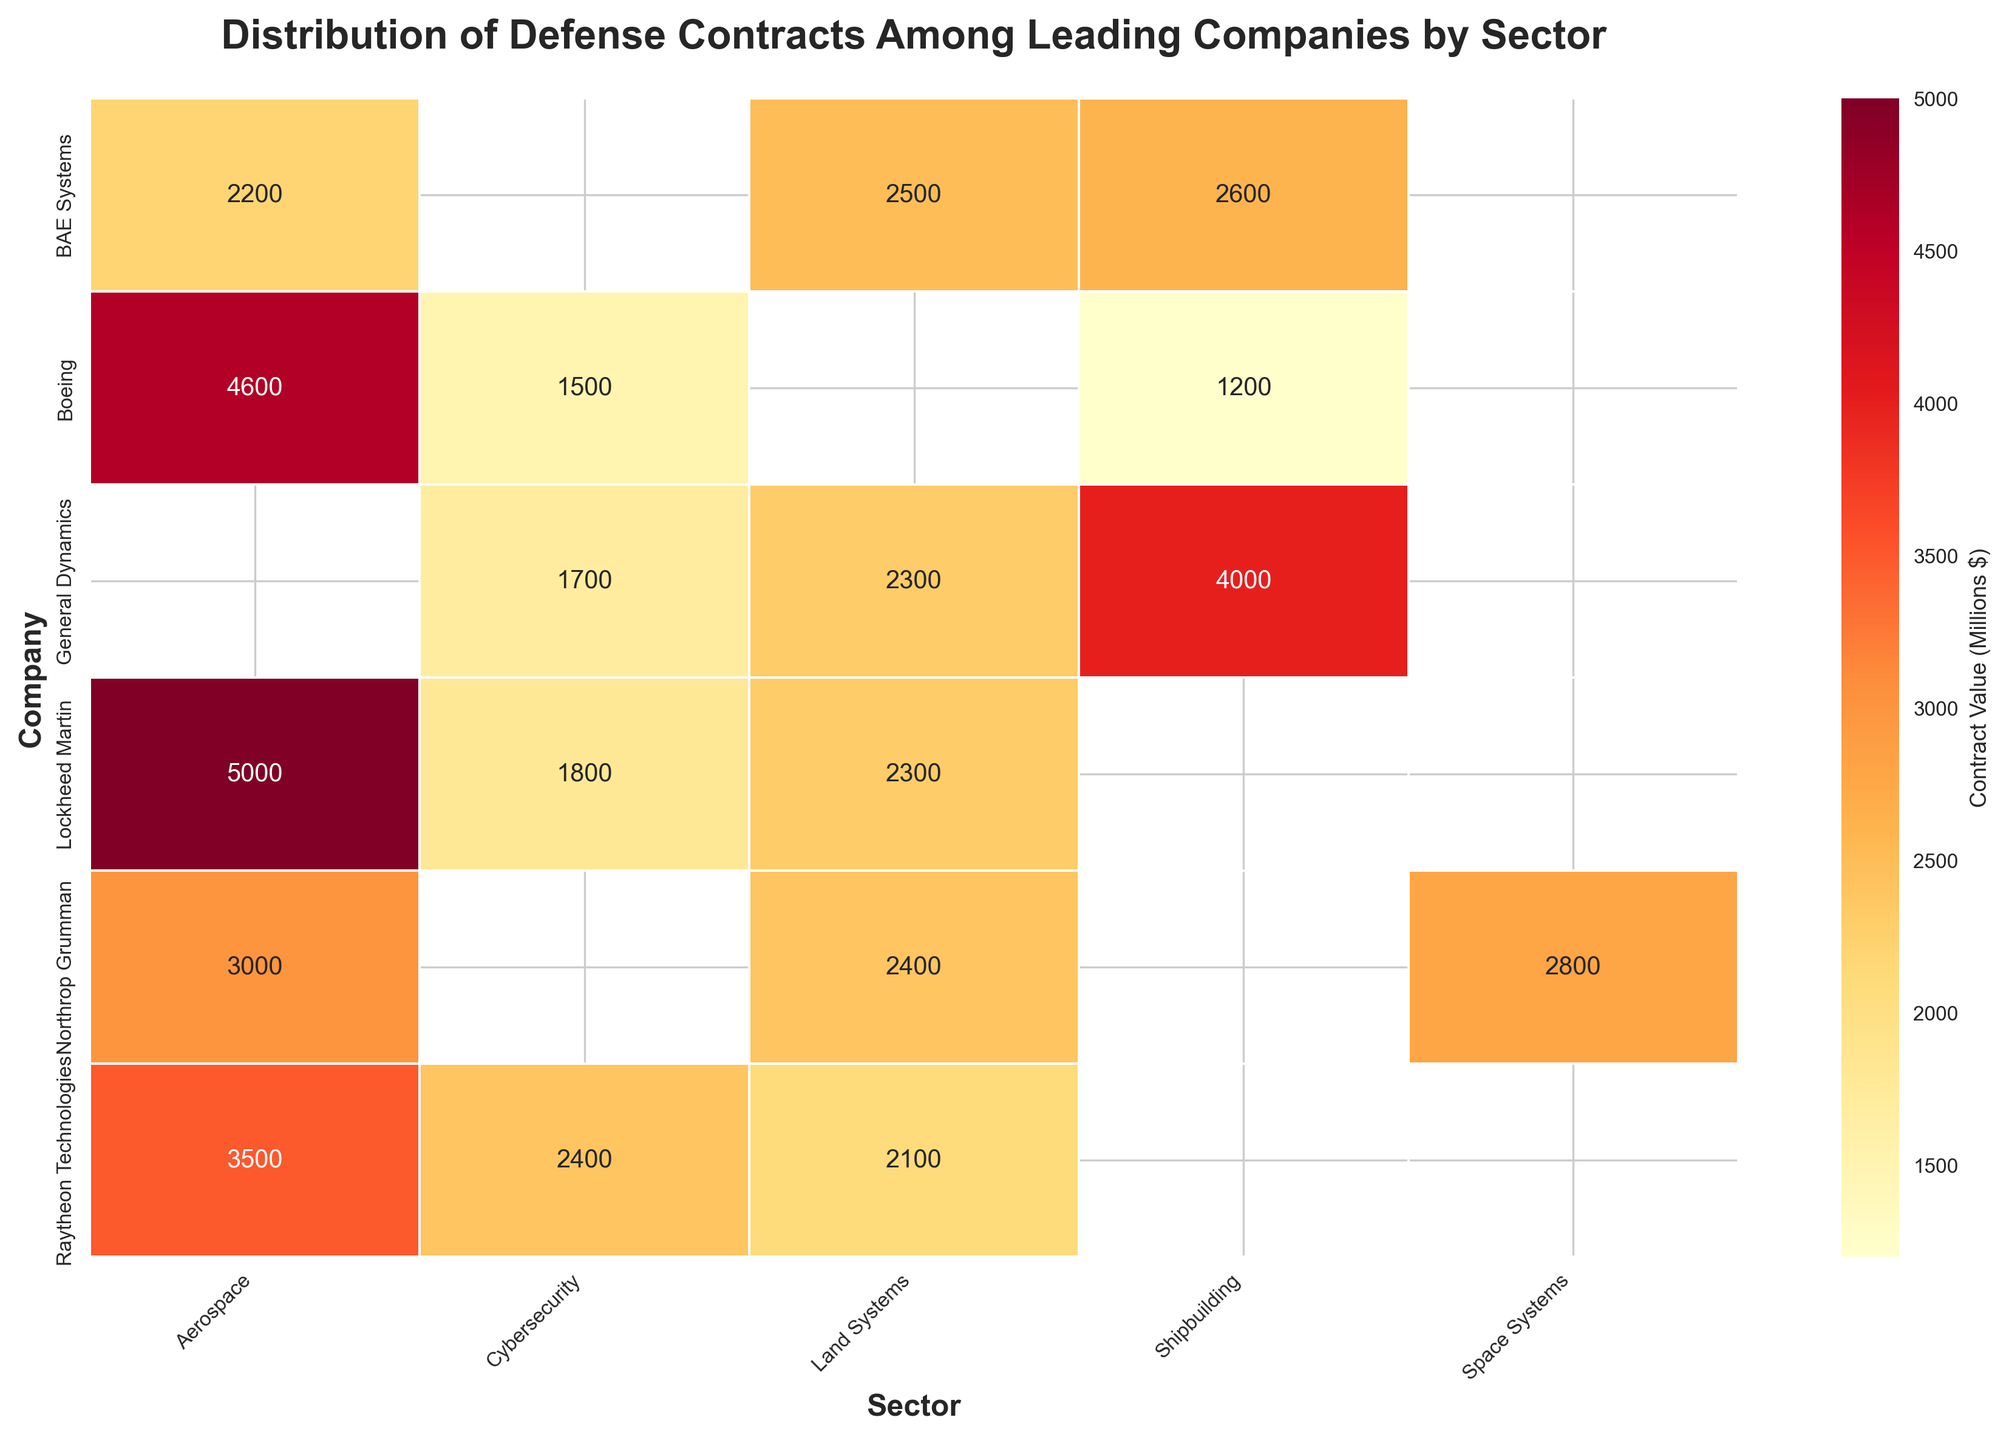what is the title of the heatmap? The title is positioned at the top of the plot. It summarizes the content of the heatmap.
Answer: Distribution of Defense Contracts Among Leading Companies by Sector Which company has the highest contract value in Aerospace? To find this, locate the column labeled 'Aerospace' and identify the highest value within that column, which corresponds to a specific company.
Answer: Lockheed Martin Which sector does Northrop Grumman have the lowest contract value in? Check the row for Northrop Grumman and find the lowest value among all its sectors.
Answer: Land Systems What's the total contract value for BAE Systems across all sectors? Add the contract values for BAE Systems in all the sectors listed. 2200 (Aerospace) + 2500 (Land Systems) + 2600 (Shipbuilding).
Answer: 7300 Compare the contract values for General Dynamics and Boeing in the Shipbuilding sector. Who has the higher value? Locate the Shipbuilding column and compare the values between General Dynamics and Boeing.
Answer: General Dynamics Which sector has the most diverse range of contract values across all companies? Observe the difference between the minimum and maximum values for each sector column and deduce which one varies the most.
Answer: Aerospace What is the average contract value for companies in the Cybersecurity sector? Add the contract values for all companies in the Cybersecurity sector and divide by the number of companies (5). (1800 + 1500 + 1700 + 2400) / 5.
Answer: 1850 Does any company have a contract value of 5000 in any sector? Scan through all the values in the heatmap to see if any sector's contract value equals 5000.
Answer: Yes, Lockheed Martin in Aerospace Which sector does Raytheon Technologies have the highest contract value in? Look at the row for Raytheon Technologies and identify the highest value within that row.
Answer: Aerospace How many sectors does Boeing have contract values listed for? Count the number of columns with non-empty values for the row corresponding to Boeing.
Answer: 3 